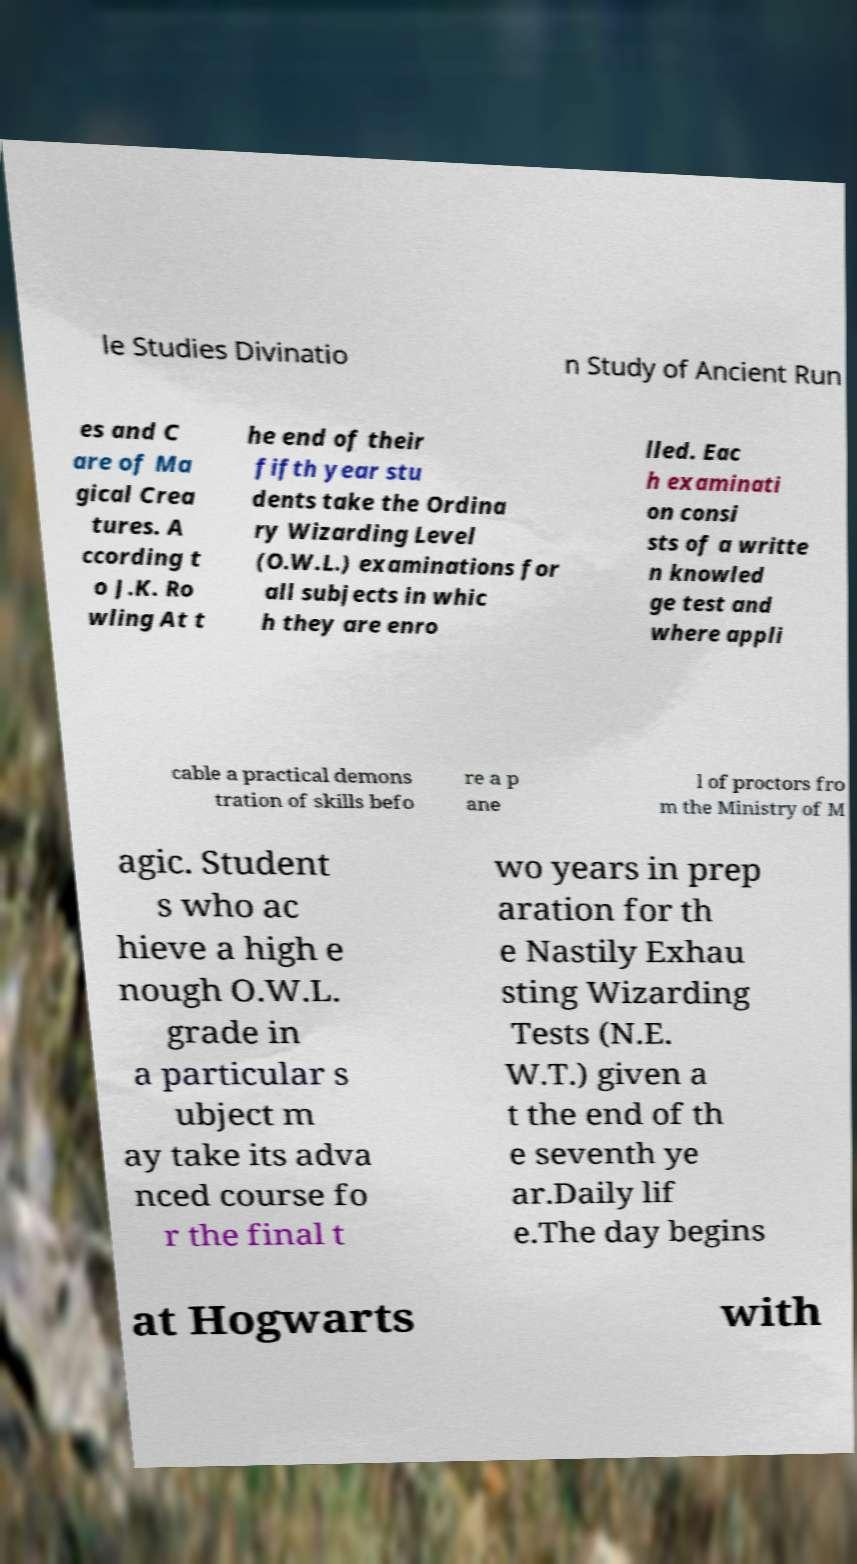Can you accurately transcribe the text from the provided image for me? le Studies Divinatio n Study of Ancient Run es and C are of Ma gical Crea tures. A ccording t o J.K. Ro wling At t he end of their fifth year stu dents take the Ordina ry Wizarding Level (O.W.L.) examinations for all subjects in whic h they are enro lled. Eac h examinati on consi sts of a writte n knowled ge test and where appli cable a practical demons tration of skills befo re a p ane l of proctors fro m the Ministry of M agic. Student s who ac hieve a high e nough O.W.L. grade in a particular s ubject m ay take its adva nced course fo r the final t wo years in prep aration for th e Nastily Exhau sting Wizarding Tests (N.E. W.T.) given a t the end of th e seventh ye ar.Daily lif e.The day begins at Hogwarts with 